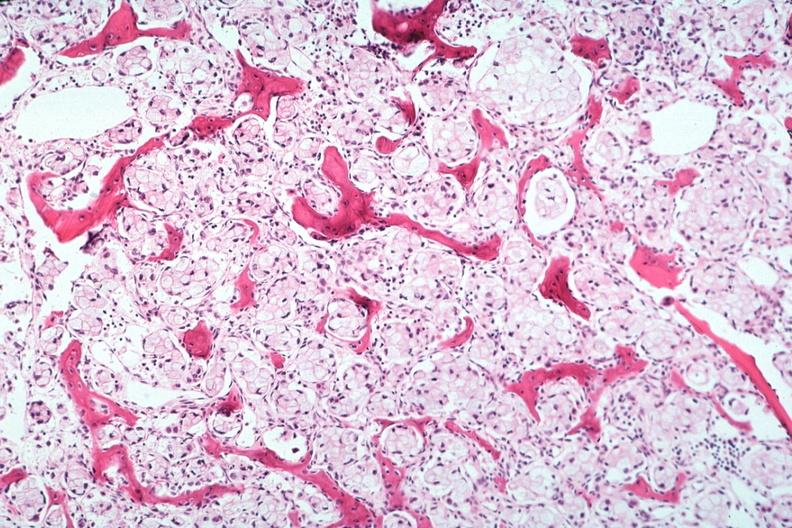does this image show stomach primary?
Answer the question using a single word or phrase. Yes 